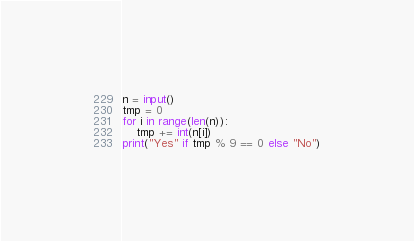<code> <loc_0><loc_0><loc_500><loc_500><_Python_>n = input()
tmp = 0
for i in range(len(n)):
    tmp += int(n[i])
print("Yes" if tmp % 9 == 0 else "No")</code> 